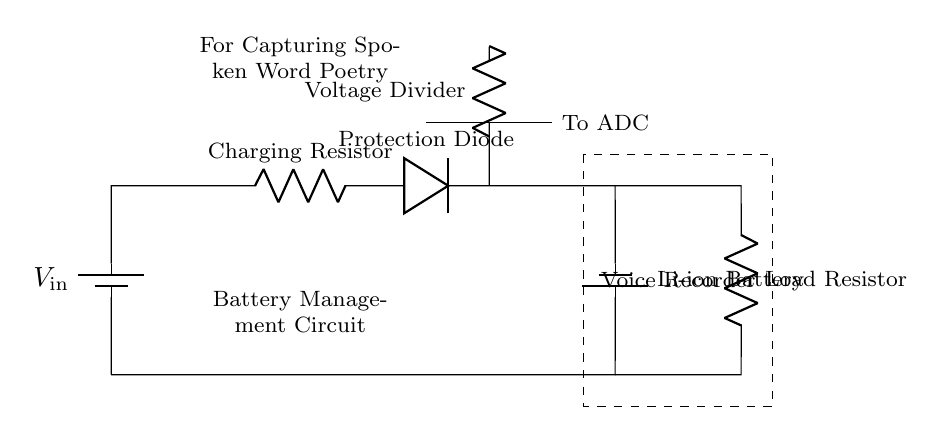What is the type of battery used in this circuit? The circuit specifies a lithium-ion battery, which is labeled as such in the diagram.
Answer: Lithium-ion battery What is the purpose of the protection diode? The protection diode prevents current from flowing back into the circuit, thus protecting the battery and providing proper charging functionality.
Answer: To prevent backflow current What component provides the load in this circuit? The load resistor is directly connected to the battery and is noted in the diagram, serving to regulate power usage by the voice recorder.
Answer: Load Resistor What is the function of the voltage divider in the circuit? The voltage divider reduces the voltage to a level suitable for an analog-to-digital converter (ADC), allowing accurate readings of the battery voltage.
Answer: To provide a suitable voltage level to ADC How many components connect directly to the battery's positive terminal? Four components connect to the positive terminal: the charging resistor, protection diode, load resistor, and voltage divider, all illustrated as branching from that point.
Answer: Four components What is indicated by the dashed rectangle in the diagram? The dashed rectangle outlines the section of the circuit specifically designated for the voice recorder, indicating that it is part of the overall battery management system.
Answer: Voice Recorder What is the significance of the charging resistor in the circuit? The charging resistor controls the charging current flowing into the lithium-ion battery. It is crucial for regulating battery charging to prevent damage.
Answer: To control charging current 